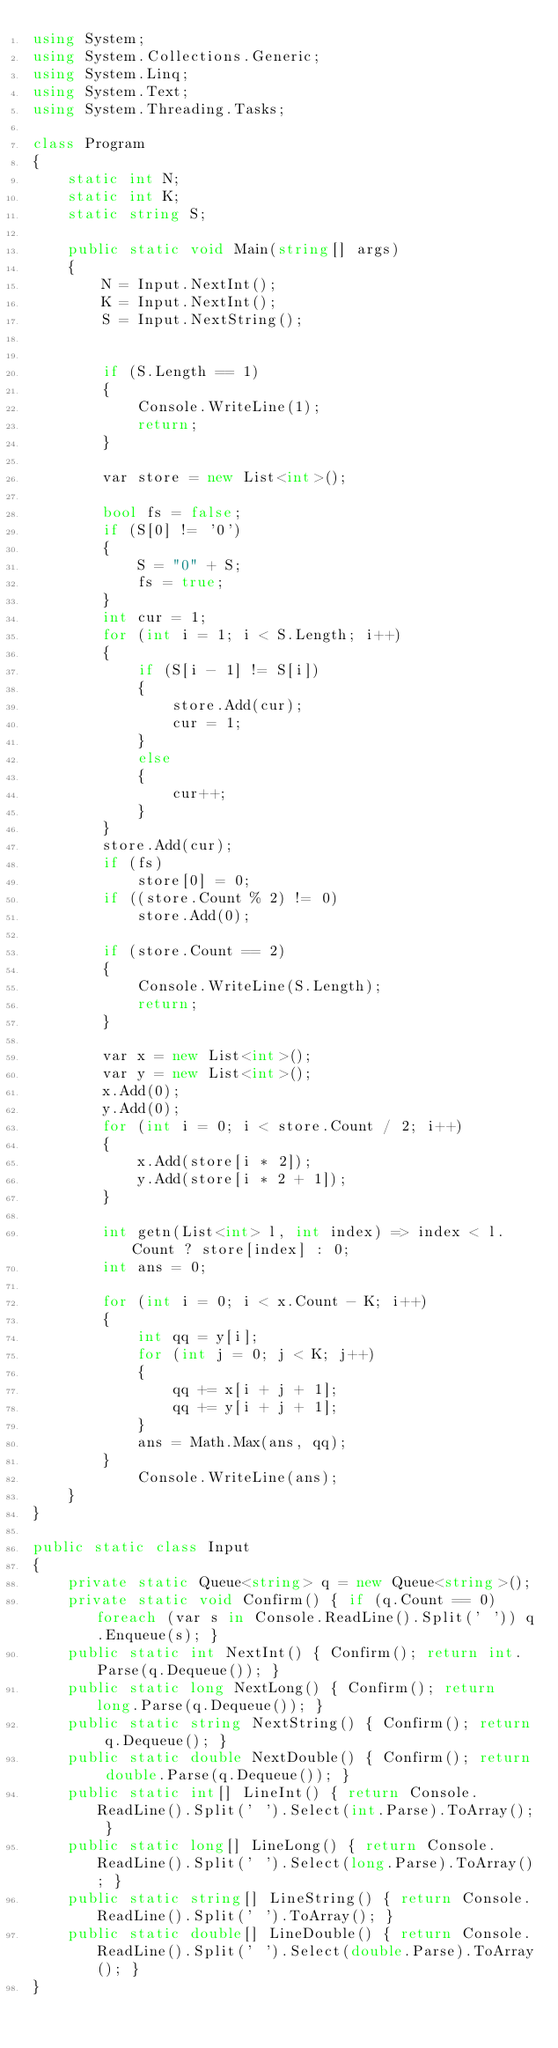<code> <loc_0><loc_0><loc_500><loc_500><_C#_>using System;
using System.Collections.Generic;
using System.Linq;
using System.Text;
using System.Threading.Tasks;

class Program
{
    static int N;
    static int K;
    static string S;

    public static void Main(string[] args)
    {
        N = Input.NextInt();
        K = Input.NextInt();
        S = Input.NextString();


        if (S.Length == 1)
        {
            Console.WriteLine(1);
            return;
        }

        var store = new List<int>();

        bool fs = false;
        if (S[0] != '0')
        {
            S = "0" + S;
            fs = true;
        }
        int cur = 1;
        for (int i = 1; i < S.Length; i++)
        {
            if (S[i - 1] != S[i])
            {
                store.Add(cur);
                cur = 1;
            }
            else
            {
                cur++;
            }
        }
        store.Add(cur);
        if (fs)
            store[0] = 0;
        if ((store.Count % 2) != 0)
            store.Add(0);

        if (store.Count == 2)
        {
            Console.WriteLine(S.Length);
            return;
        }

        var x = new List<int>();
        var y = new List<int>();
        x.Add(0);
        y.Add(0);
        for (int i = 0; i < store.Count / 2; i++)
        {
            x.Add(store[i * 2]);
            y.Add(store[i * 2 + 1]);
        }

        int getn(List<int> l, int index) => index < l.Count ? store[index] : 0;
        int ans = 0;

        for (int i = 0; i < x.Count - K; i++)
        {
            int qq = y[i];
            for (int j = 0; j < K; j++)
            {
                qq += x[i + j + 1];
                qq += y[i + j + 1];
            }
            ans = Math.Max(ans, qq);
        }
            Console.WriteLine(ans);
    }
}

public static class Input
{
    private static Queue<string> q = new Queue<string>();
    private static void Confirm() { if (q.Count == 0) foreach (var s in Console.ReadLine().Split(' ')) q.Enqueue(s); }
    public static int NextInt() { Confirm(); return int.Parse(q.Dequeue()); }
    public static long NextLong() { Confirm(); return long.Parse(q.Dequeue()); }
    public static string NextString() { Confirm(); return q.Dequeue(); }
    public static double NextDouble() { Confirm(); return double.Parse(q.Dequeue()); }
    public static int[] LineInt() { return Console.ReadLine().Split(' ').Select(int.Parse).ToArray(); }
    public static long[] LineLong() { return Console.ReadLine().Split(' ').Select(long.Parse).ToArray(); }
    public static string[] LineString() { return Console.ReadLine().Split(' ').ToArray(); }
    public static double[] LineDouble() { return Console.ReadLine().Split(' ').Select(double.Parse).ToArray(); }
}</code> 